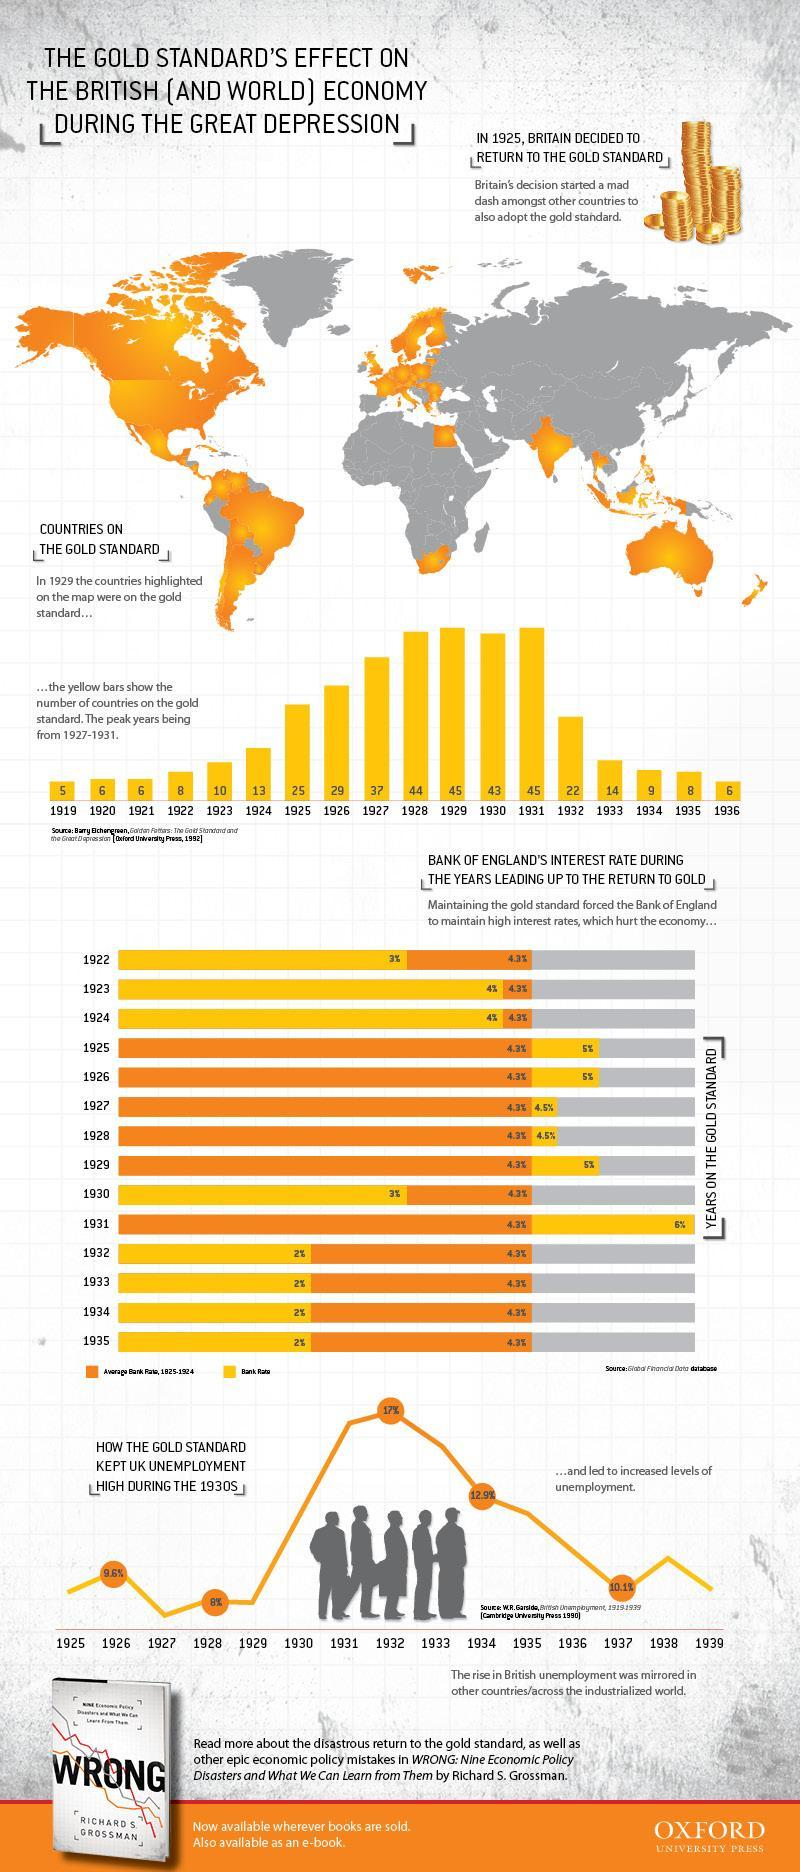How many countries were on the gold standard in 1924?
Answer the question with a short phrase. 13 How many countries were on the gold standard in 1931? 45 